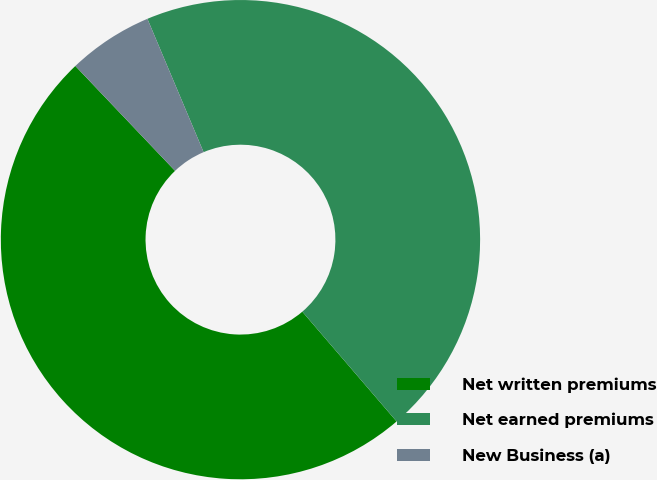<chart> <loc_0><loc_0><loc_500><loc_500><pie_chart><fcel>Net written premiums<fcel>Net earned premiums<fcel>New Business (a)<nl><fcel>49.19%<fcel>45.05%<fcel>5.75%<nl></chart> 